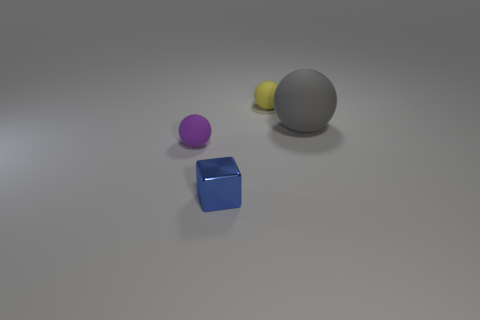Add 1 brown rubber things. How many objects exist? 5 Subtract all blocks. How many objects are left? 3 Subtract all cyan rubber cylinders. Subtract all matte spheres. How many objects are left? 1 Add 4 tiny objects. How many tiny objects are left? 7 Add 3 metallic blocks. How many metallic blocks exist? 4 Subtract 0 green balls. How many objects are left? 4 